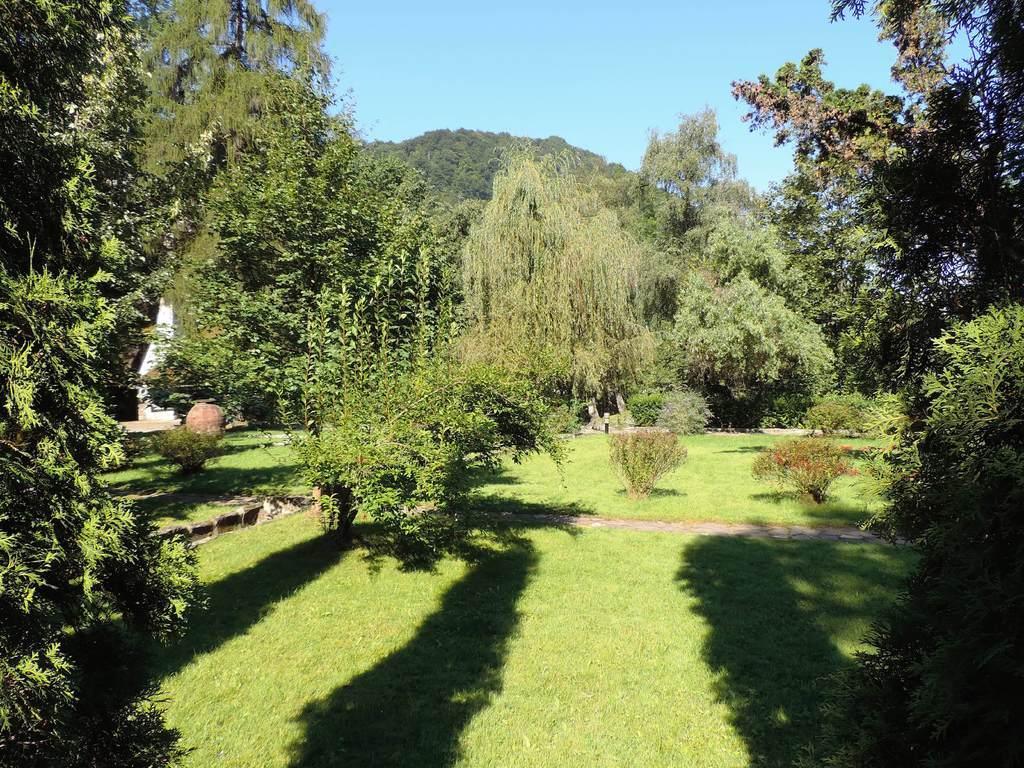Describe this image in one or two sentences. In this image we can see many trees and some plants. Image also consists of a mountain with full of trees. At the top there is sky and at the bottom there is grass. 